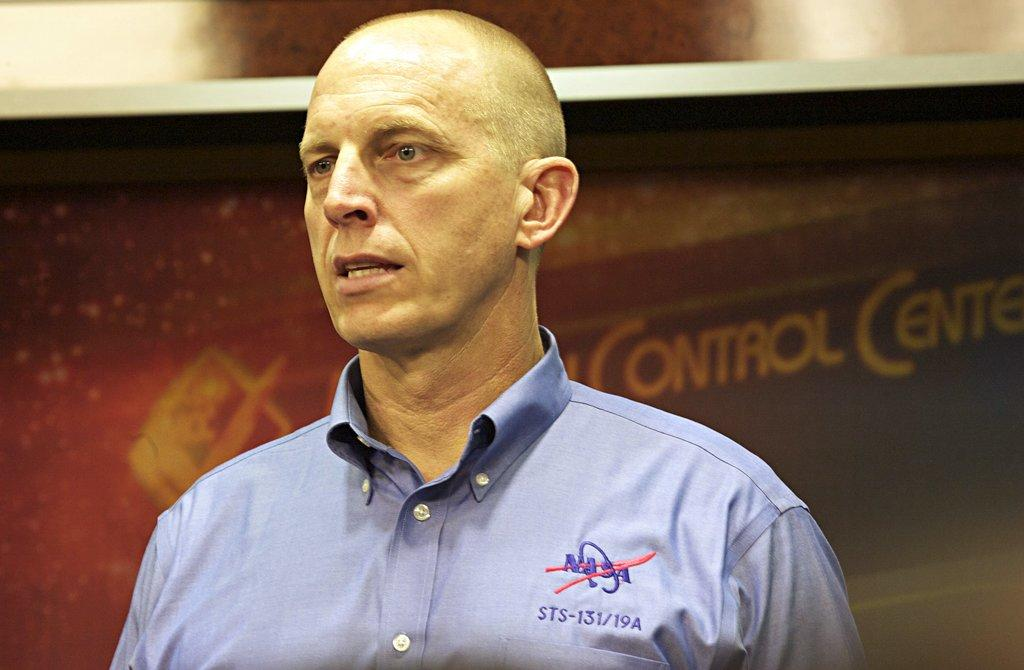Who is the main subject in the image? There is a person in the center of the image. What is the person doing in the image? The person appears to be talking. What can be seen in the background of the image? There is text, a possible board, a wall, and an unspecified object visible in the background of the image. What type of stove can be seen in the image? There is no stove present in the image. Can you tell me how many bats are flying in the background of the image? There are no bats visible in the image. 